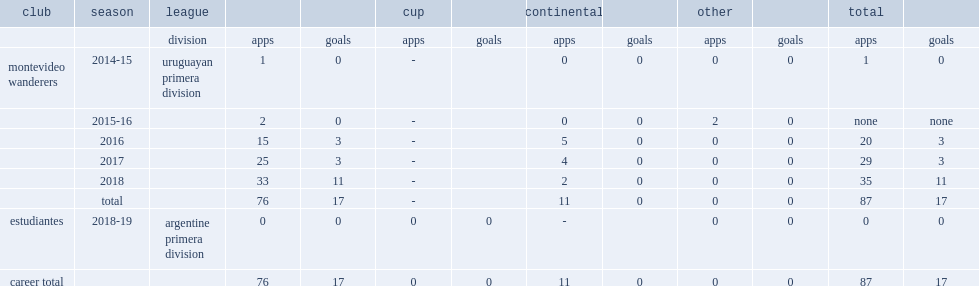Which club did castro play for in 2014-15? Montevideo wanderers. 